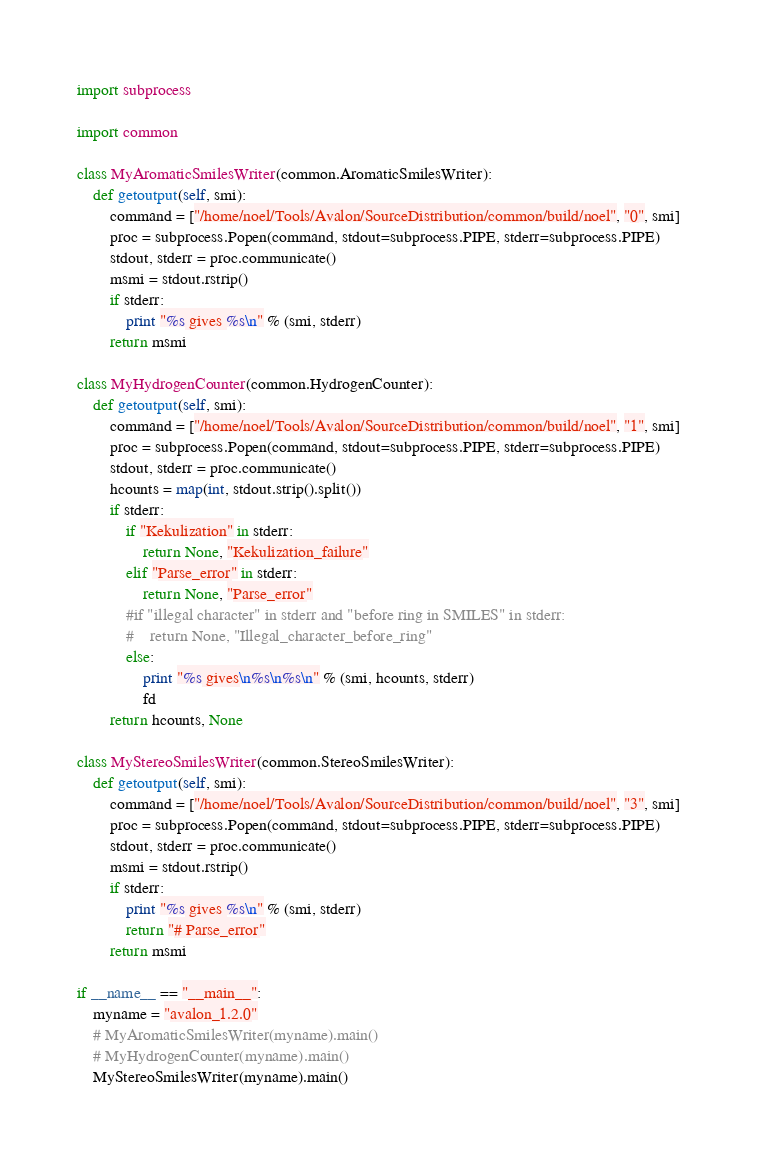<code> <loc_0><loc_0><loc_500><loc_500><_Python_>import subprocess

import common

class MyAromaticSmilesWriter(common.AromaticSmilesWriter):
    def getoutput(self, smi):
        command = ["/home/noel/Tools/Avalon/SourceDistribution/common/build/noel", "0", smi]
        proc = subprocess.Popen(command, stdout=subprocess.PIPE, stderr=subprocess.PIPE)
        stdout, stderr = proc.communicate()
        msmi = stdout.rstrip()
        if stderr:
            print "%s gives %s\n" % (smi, stderr)
        return msmi

class MyHydrogenCounter(common.HydrogenCounter):
    def getoutput(self, smi):
        command = ["/home/noel/Tools/Avalon/SourceDistribution/common/build/noel", "1", smi]
        proc = subprocess.Popen(command, stdout=subprocess.PIPE, stderr=subprocess.PIPE)
        stdout, stderr = proc.communicate()
        hcounts = map(int, stdout.strip().split())
        if stderr:
            if "Kekulization" in stderr:
                return None, "Kekulization_failure"
            elif "Parse_error" in stderr:
                return None, "Parse_error"
            #if "illegal character" in stderr and "before ring in SMILES" in stderr:
            #    return None, "Illegal_character_before_ring"
            else:
                print "%s gives\n%s\n%s\n" % (smi, hcounts, stderr)
                fd
        return hcounts, None

class MyStereoSmilesWriter(common.StereoSmilesWriter):
    def getoutput(self, smi):
        command = ["/home/noel/Tools/Avalon/SourceDistribution/common/build/noel", "3", smi]
        proc = subprocess.Popen(command, stdout=subprocess.PIPE, stderr=subprocess.PIPE)
        stdout, stderr = proc.communicate()
        msmi = stdout.rstrip()
        if stderr:
            print "%s gives %s\n" % (smi, stderr)
            return "# Parse_error"
        return msmi

if __name__ == "__main__":
    myname = "avalon_1.2.0"
    # MyAromaticSmilesWriter(myname).main()
    # MyHydrogenCounter(myname).main()
    MyStereoSmilesWriter(myname).main()

</code> 